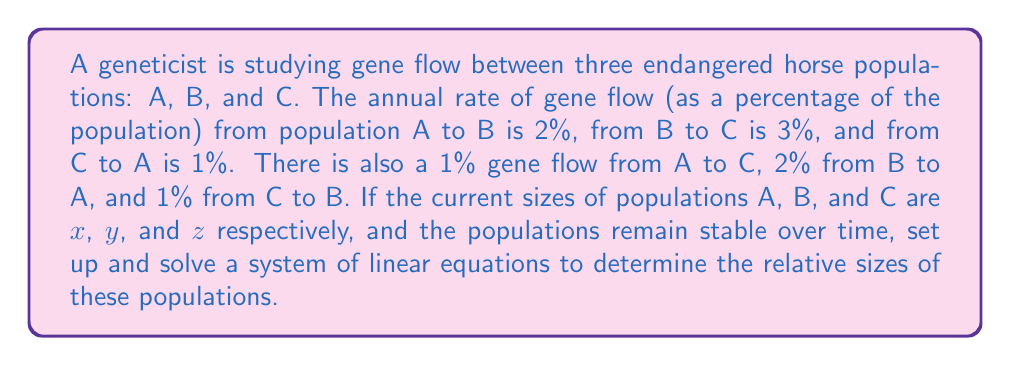Can you answer this question? To solve this problem, we need to set up a system of linear equations based on the gene flow between populations. Let's approach this step-by-step:

1) First, let's set up equations for each population, considering inflows and outflows:

   For population A:
   $x = 0.98x + 0.02y + 0.01z$

   For population B:
   $y = 0.02x + 0.95y + 0.01z$

   For population C:
   $z = 0.01x + 0.03y + 0.98z$

2) Rearrange each equation to standard form:

   $0.02x - 0.02y - 0.01z = 0$
   $-0.02x + 0.05y - 0.01z = 0$
   $-0.01x - 0.03y + 0.02z = 0$

3) This system can be represented in matrix form as:

   $$
   \begin{bmatrix}
   0.02 & -0.02 & -0.01 \\
   -0.02 & 0.05 & -0.01 \\
   -0.01 & -0.03 & 0.02
   \end{bmatrix}
   \begin{bmatrix}
   x \\
   y \\
   z
   \end{bmatrix}
   =
   \begin{bmatrix}
   0 \\
   0 \\
   0
   \end{bmatrix}
   $$

4) To find a non-trivial solution, we need to find the nullspace of this matrix. We can do this by row reducing the matrix:

   $$
   \begin{bmatrix}
   1 & -1 & -0.5 \\
   0 & 1 & -0.25 \\
   0 & 0 & 0
   \end{bmatrix}
   $$

5) From this reduced form, we can see that $z$ is a free variable. Let $z = 4$ (we choose 4 to avoid fractions in our final answer).

6) Working backwards:
   $y - 0.25z = 0$, so $y = 0.25z = 1$
   $x - y - 0.5z = 0$, so $x = y + 0.5z = 1 + 2 = 3$

Therefore, the relative sizes of the populations are:
$x : y : z = 3 : 1 : 4$
Answer: The relative sizes of populations A, B, and C are 3 : 1 : 4, respectively. 